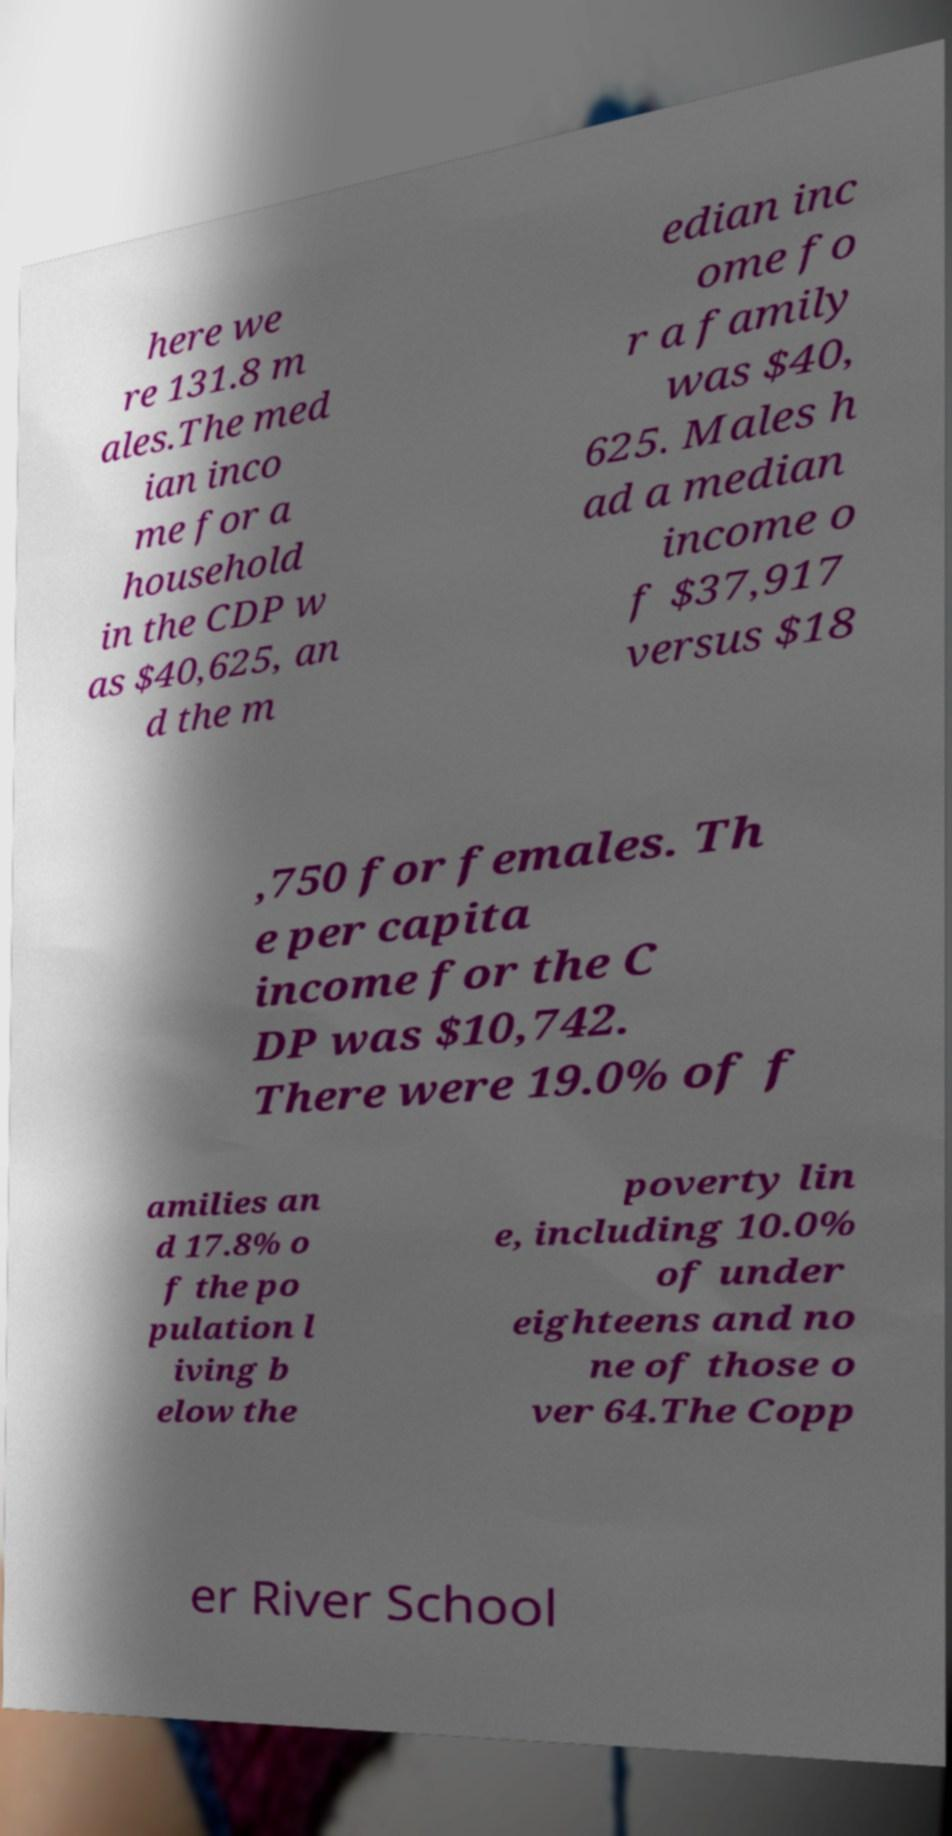There's text embedded in this image that I need extracted. Can you transcribe it verbatim? here we re 131.8 m ales.The med ian inco me for a household in the CDP w as $40,625, an d the m edian inc ome fo r a family was $40, 625. Males h ad a median income o f $37,917 versus $18 ,750 for females. Th e per capita income for the C DP was $10,742. There were 19.0% of f amilies an d 17.8% o f the po pulation l iving b elow the poverty lin e, including 10.0% of under eighteens and no ne of those o ver 64.The Copp er River School 